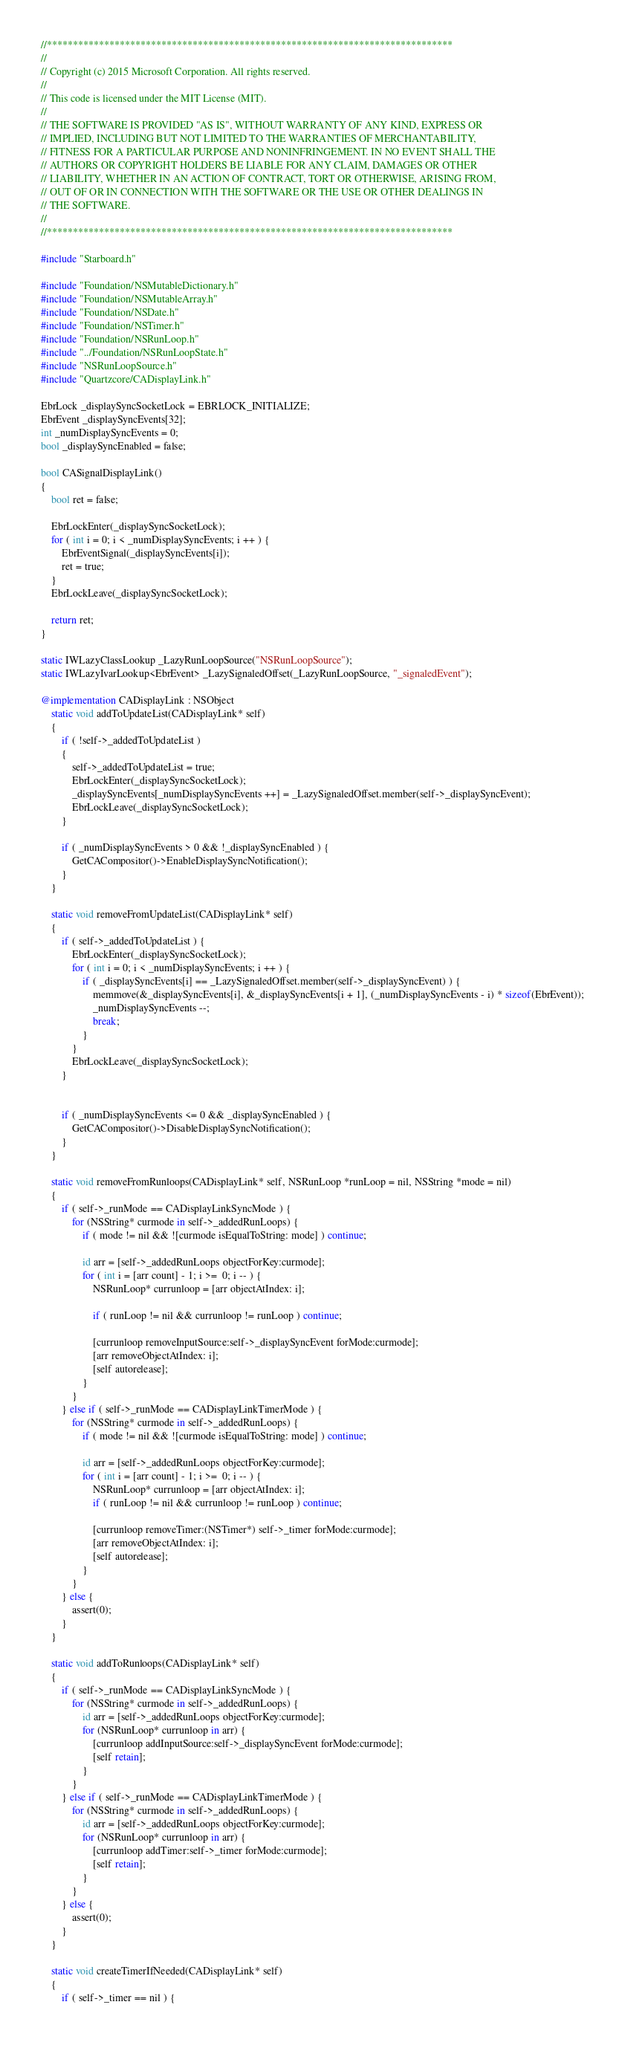<code> <loc_0><loc_0><loc_500><loc_500><_ObjectiveC_>//******************************************************************************
//
// Copyright (c) 2015 Microsoft Corporation. All rights reserved.
//
// This code is licensed under the MIT License (MIT).
//
// THE SOFTWARE IS PROVIDED "AS IS", WITHOUT WARRANTY OF ANY KIND, EXPRESS OR
// IMPLIED, INCLUDING BUT NOT LIMITED TO THE WARRANTIES OF MERCHANTABILITY,
// FITNESS FOR A PARTICULAR PURPOSE AND NONINFRINGEMENT. IN NO EVENT SHALL THE
// AUTHORS OR COPYRIGHT HOLDERS BE LIABLE FOR ANY CLAIM, DAMAGES OR OTHER
// LIABILITY, WHETHER IN AN ACTION OF CONTRACT, TORT OR OTHERWISE, ARISING FROM,
// OUT OF OR IN CONNECTION WITH THE SOFTWARE OR THE USE OR OTHER DEALINGS IN
// THE SOFTWARE.
//
//******************************************************************************

#include "Starboard.h"

#include "Foundation/NSMutableDictionary.h"
#include "Foundation/NSMutableArray.h"
#include "Foundation/NSDate.h"
#include "Foundation/NSTimer.h"
#include "Foundation/NSRunLoop.h"
#include "../Foundation/NSRunLoopState.h"
#include "NSRunLoopSource.h"
#include "Quartzcore/CADisplayLink.h"

EbrLock _displaySyncSocketLock = EBRLOCK_INITIALIZE;
EbrEvent _displaySyncEvents[32];
int _numDisplaySyncEvents = 0;
bool _displaySyncEnabled = false;

bool CASignalDisplayLink()
{
    bool ret = false;

    EbrLockEnter(_displaySyncSocketLock);
    for ( int i = 0; i < _numDisplaySyncEvents; i ++ ) {
        EbrEventSignal(_displaySyncEvents[i]);
        ret = true;
    }
    EbrLockLeave(_displaySyncSocketLock);

    return ret;
}

static IWLazyClassLookup _LazyRunLoopSource("NSRunLoopSource");
static IWLazyIvarLookup<EbrEvent> _LazySignaledOffset(_LazyRunLoopSource, "_signaledEvent");

@implementation CADisplayLink : NSObject
    static void addToUpdateList(CADisplayLink* self)
    {
        if ( !self->_addedToUpdateList )
        {
            self->_addedToUpdateList = true;
            EbrLockEnter(_displaySyncSocketLock);
            _displaySyncEvents[_numDisplaySyncEvents ++] = _LazySignaledOffset.member(self->_displaySyncEvent);
            EbrLockLeave(_displaySyncSocketLock);
        }

        if ( _numDisplaySyncEvents > 0 && !_displaySyncEnabled ) {
            GetCACompositor()->EnableDisplaySyncNotification();
        }
    }

    static void removeFromUpdateList(CADisplayLink* self)
    {
        if ( self->_addedToUpdateList ) {
            EbrLockEnter(_displaySyncSocketLock);
            for ( int i = 0; i < _numDisplaySyncEvents; i ++ ) {
                if ( _displaySyncEvents[i] == _LazySignaledOffset.member(self->_displaySyncEvent) ) {
                    memmove(&_displaySyncEvents[i], &_displaySyncEvents[i + 1], (_numDisplaySyncEvents - i) * sizeof(EbrEvent));
                    _numDisplaySyncEvents --;
                    break;
                }
            }
            EbrLockLeave(_displaySyncSocketLock);
        }


        if ( _numDisplaySyncEvents <= 0 && _displaySyncEnabled ) {
            GetCACompositor()->DisableDisplaySyncNotification();
        }
    }

    static void removeFromRunloops(CADisplayLink* self, NSRunLoop *runLoop = nil, NSString *mode = nil)
    {
        if ( self->_runMode == CADisplayLinkSyncMode ) {
            for (NSString* curmode in self->_addedRunLoops) {
                if ( mode != nil && ![curmode isEqualToString: mode] ) continue;

                id arr = [self->_addedRunLoops objectForKey:curmode];
                for ( int i = [arr count] - 1; i >=  0; i -- ) {
                    NSRunLoop* currunloop = [arr objectAtIndex: i];

                    if ( runLoop != nil && currunloop != runLoop ) continue;

                    [currunloop removeInputSource:self->_displaySyncEvent forMode:curmode];
                    [arr removeObjectAtIndex: i];
                    [self autorelease];
                }
            }
        } else if ( self->_runMode == CADisplayLinkTimerMode ) {
            for (NSString* curmode in self->_addedRunLoops) {
                if ( mode != nil && ![curmode isEqualToString: mode] ) continue;

                id arr = [self->_addedRunLoops objectForKey:curmode];
                for ( int i = [arr count] - 1; i >=  0; i -- ) {
                    NSRunLoop* currunloop = [arr objectAtIndex: i];
                    if ( runLoop != nil && currunloop != runLoop ) continue;

                    [currunloop removeTimer:(NSTimer*) self->_timer forMode:curmode];
                    [arr removeObjectAtIndex: i];
                    [self autorelease];
                }
            }
        } else {
            assert(0);
        }
    }

    static void addToRunloops(CADisplayLink* self)
    {
        if ( self->_runMode == CADisplayLinkSyncMode ) {
            for (NSString* curmode in self->_addedRunLoops) {
                id arr = [self->_addedRunLoops objectForKey:curmode];
                for (NSRunLoop* currunloop in arr) {
                    [currunloop addInputSource:self->_displaySyncEvent forMode:curmode];
                    [self retain];
                }
            }
        } else if ( self->_runMode == CADisplayLinkTimerMode ) {
            for (NSString* curmode in self->_addedRunLoops) {
                id arr = [self->_addedRunLoops objectForKey:curmode];
                for (NSRunLoop* currunloop in arr) {
                    [currunloop addTimer:self->_timer forMode:curmode];
                    [self retain];
                }
            }
        } else {
            assert(0);
        }
    }

    static void createTimerIfNeeded(CADisplayLink* self)
    {
        if ( self->_timer == nil ) {</code> 